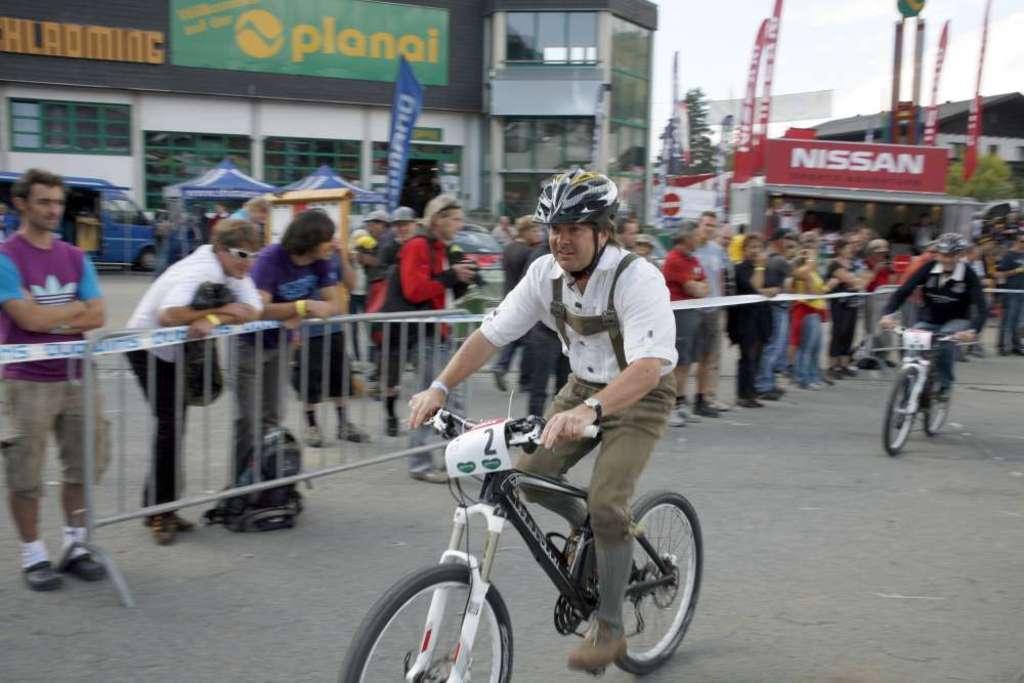Could you give a brief overview of what you see in this image? In this picture there is a man riding a bicycle. There is also another man riding a bicycle. There are few people who are standing at the background. There is a building, tree , stalls and a car. 